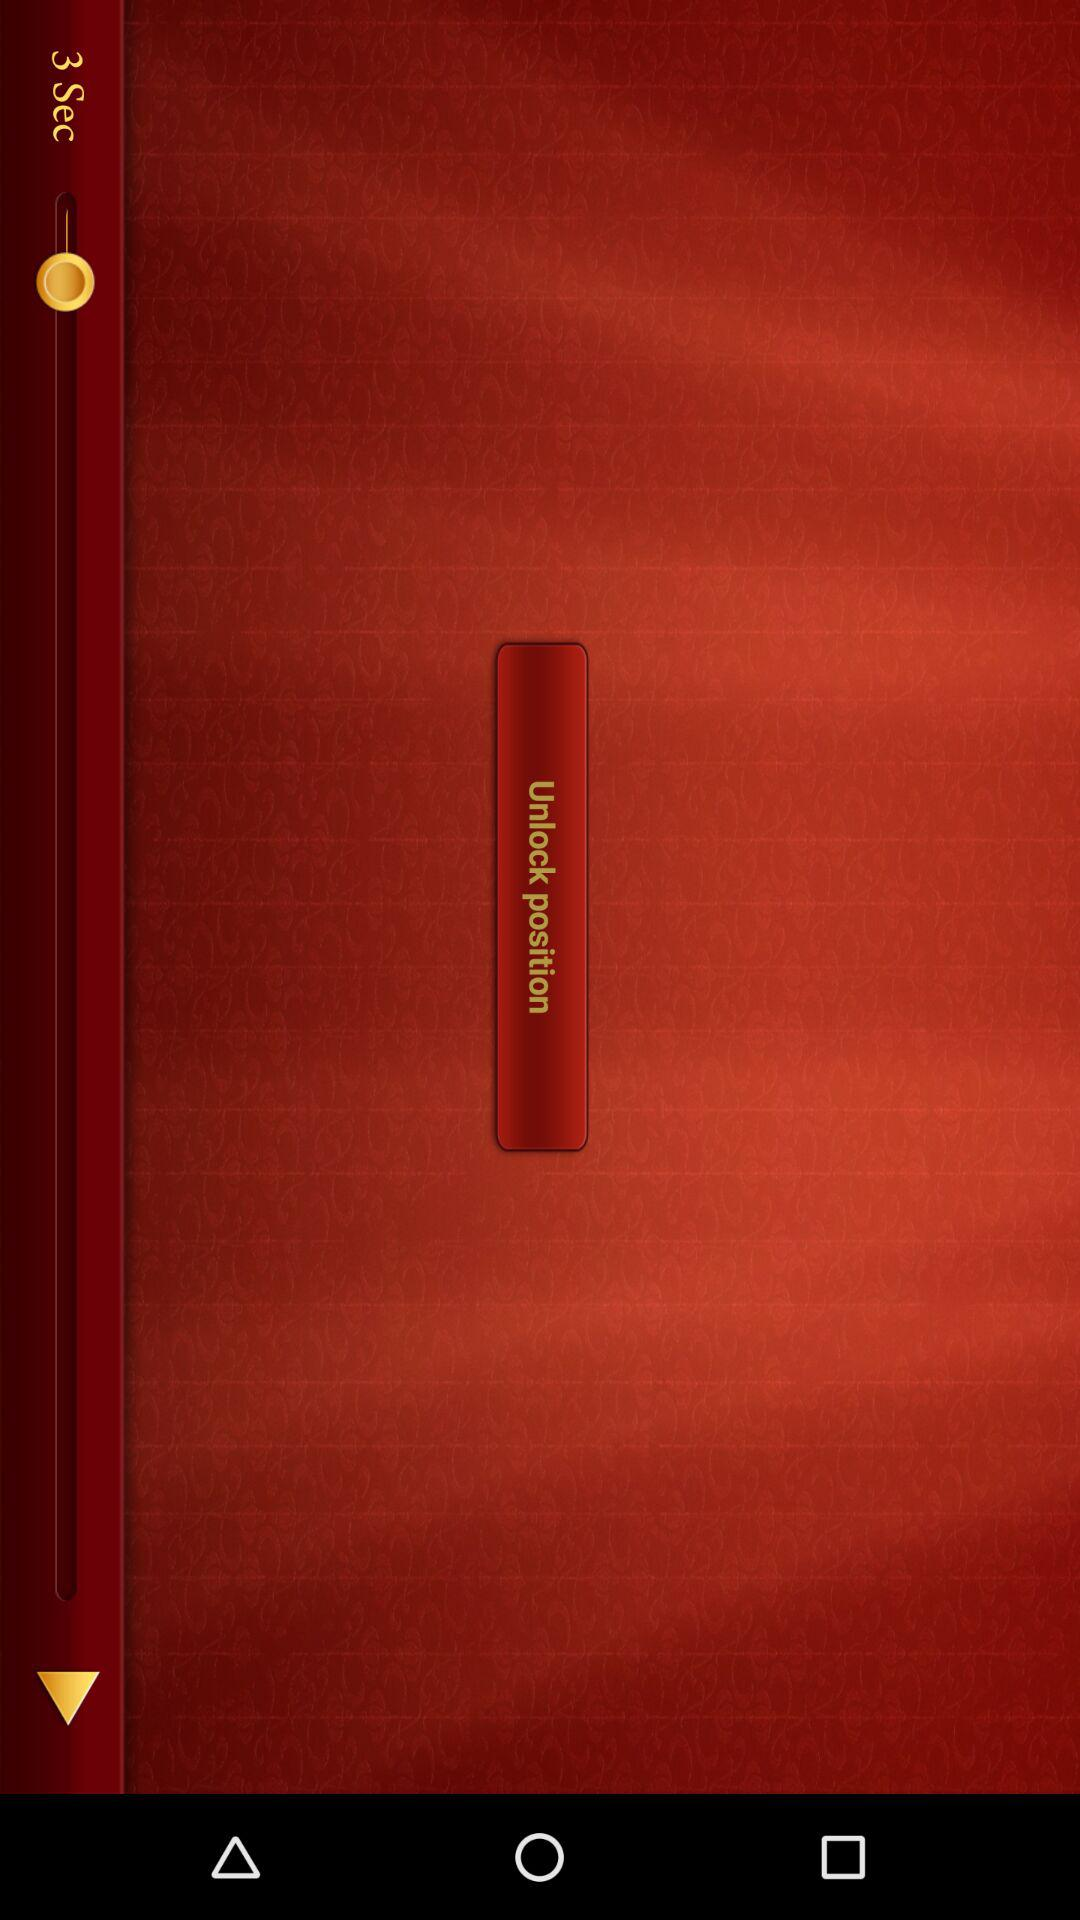What is the given percentage of "Affordable"? The given percentage of "Affordable" is 0. 